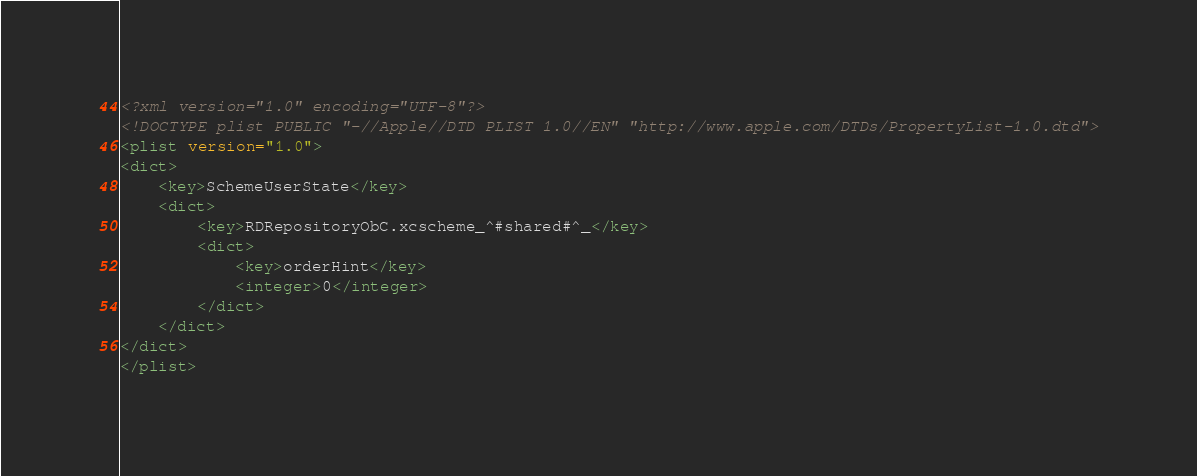<code> <loc_0><loc_0><loc_500><loc_500><_XML_><?xml version="1.0" encoding="UTF-8"?>
<!DOCTYPE plist PUBLIC "-//Apple//DTD PLIST 1.0//EN" "http://www.apple.com/DTDs/PropertyList-1.0.dtd">
<plist version="1.0">
<dict>
	<key>SchemeUserState</key>
	<dict>
		<key>RDRepositoryObC.xcscheme_^#shared#^_</key>
		<dict>
			<key>orderHint</key>
			<integer>0</integer>
		</dict>
	</dict>
</dict>
</plist>
</code> 